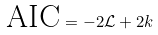<formula> <loc_0><loc_0><loc_500><loc_500>\text {AIC} = - 2 \mathcal { L } + 2 k</formula> 